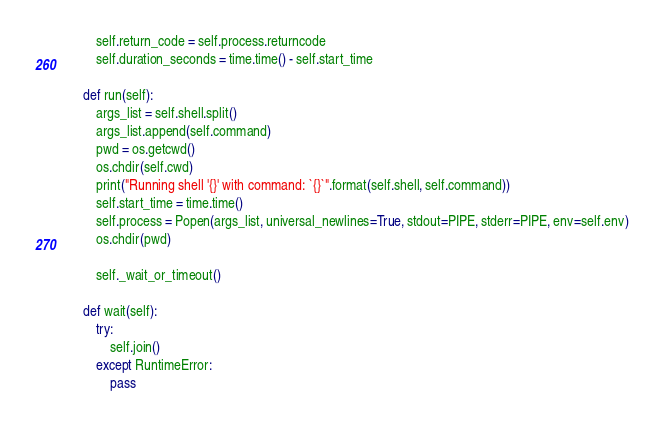<code> <loc_0><loc_0><loc_500><loc_500><_Python_>
        self.return_code = self.process.returncode
        self.duration_seconds = time.time() - self.start_time

    def run(self):
        args_list = self.shell.split()
        args_list.append(self.command)
        pwd = os.getcwd()
        os.chdir(self.cwd)
        print("Running shell '{}' with command: `{}`".format(self.shell, self.command))
        self.start_time = time.time()
        self.process = Popen(args_list, universal_newlines=True, stdout=PIPE, stderr=PIPE, env=self.env)
        os.chdir(pwd)

        self._wait_or_timeout()

    def wait(self):
        try:
            self.join()
        except RuntimeError:
            pass
</code> 